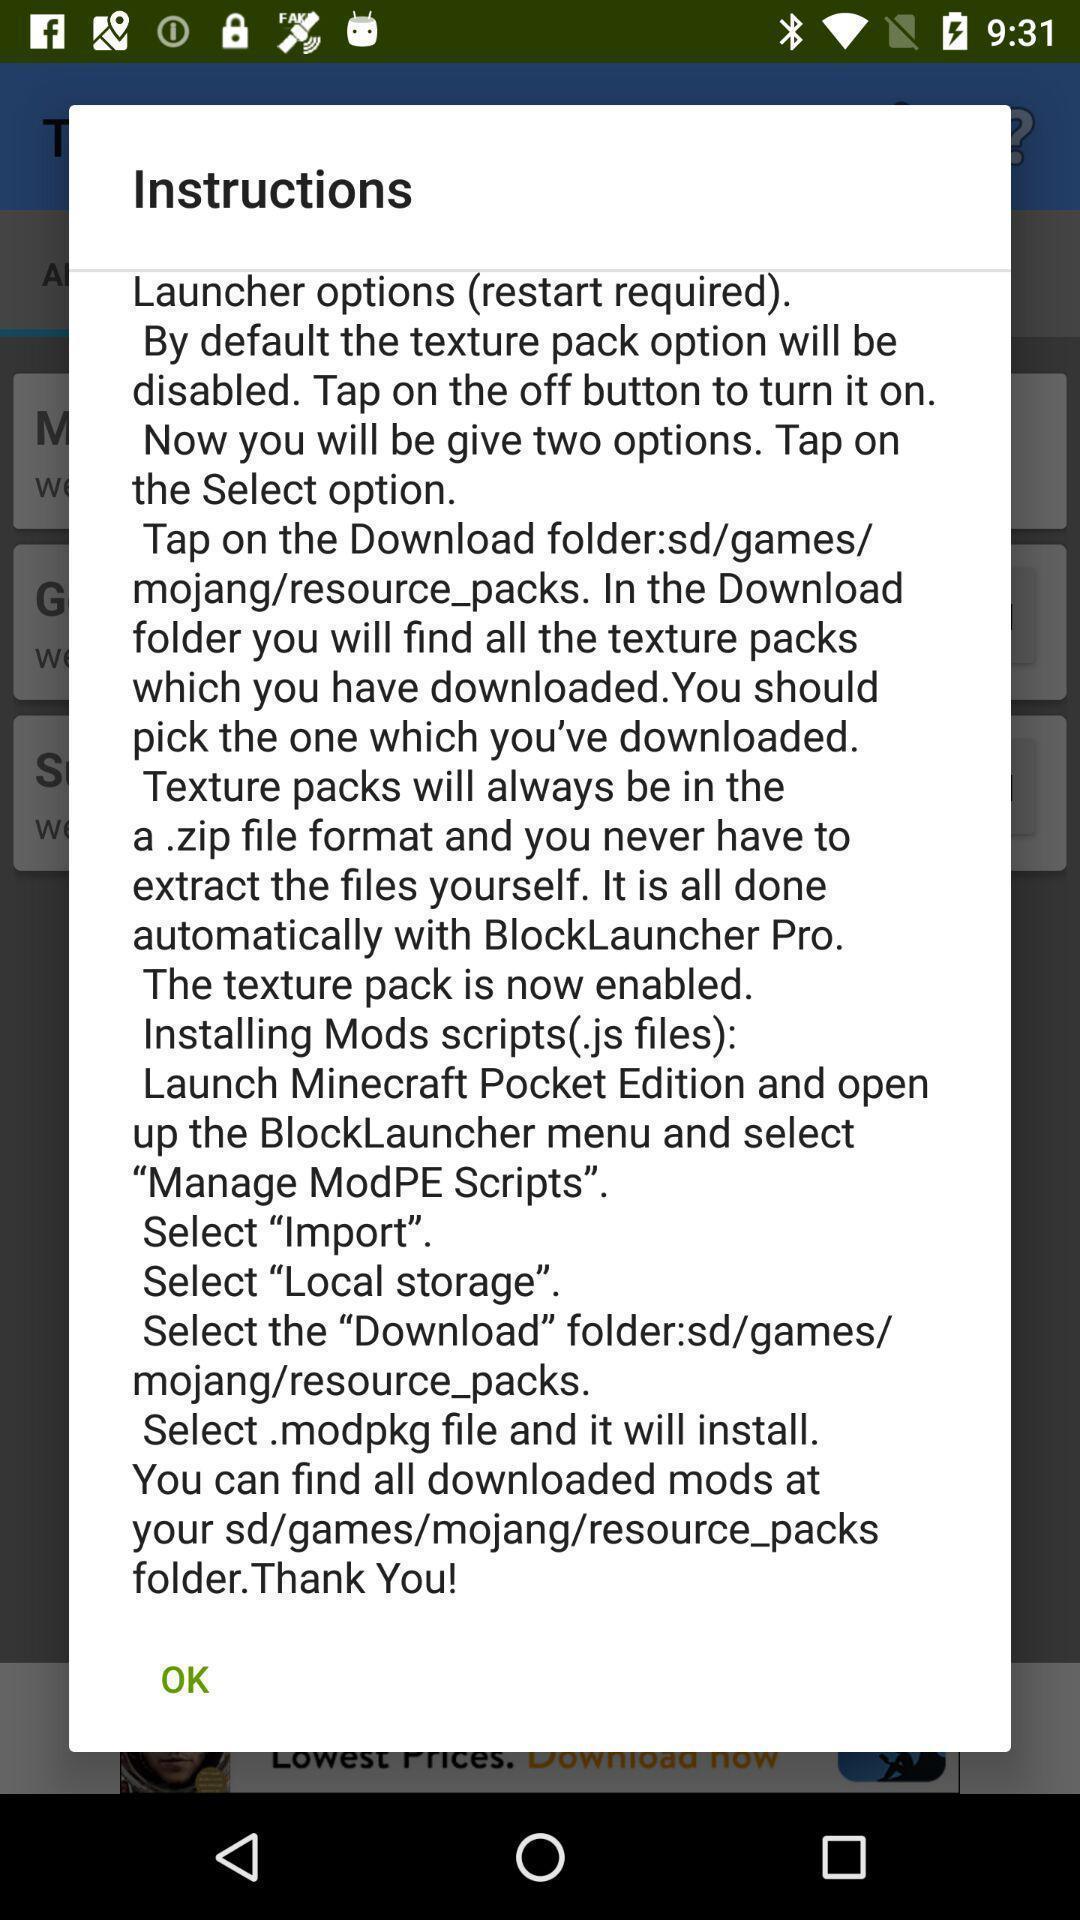Tell me about the visual elements in this screen capture. Pop-up window showing instructions of the app. 